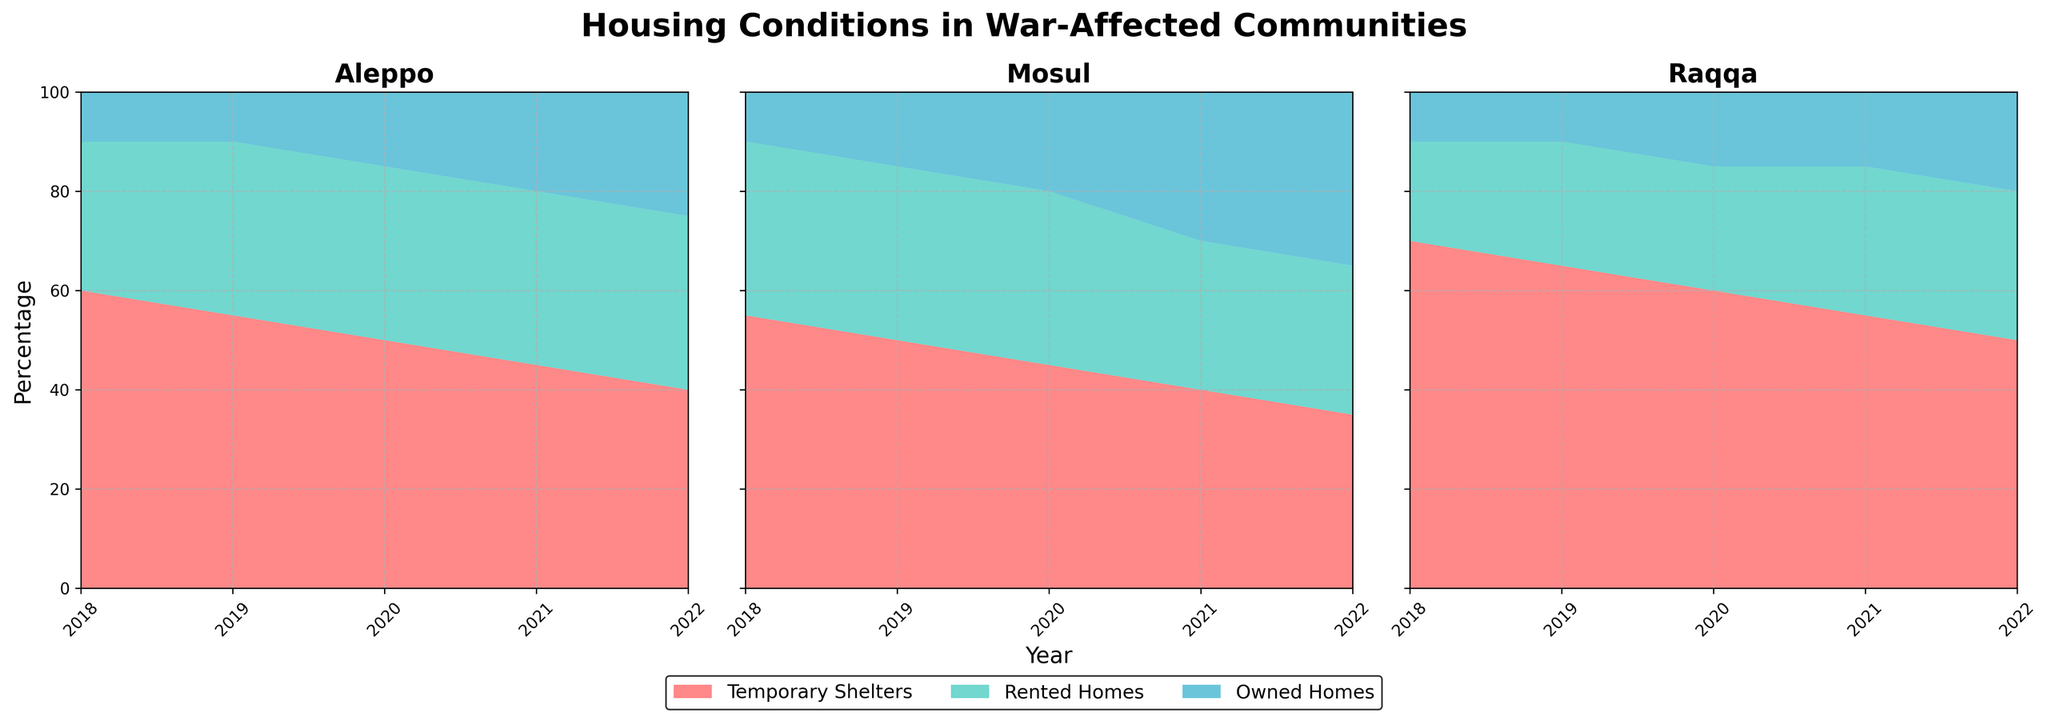What is the title of the chart? The title is given at the top of the chart and typically describes the main topic or focus of the figure.
Answer: Housing Conditions in War-Affected Communities Which community had the highest percentage of temporary shelters in 2018? Look at the stack for 2018 and compare the height of the temporary shelters area for each community.
Answer: Raqqa In Aleppo, how did the percentage of owned homes change from 2018 to 2022? Observe the height of the owned homes area in Aleppo's segment from 2018 to 2022 to see how it changed over the years.
Answer: Increased from 10% to 25% Which community showed the most significant change in the percentage of rented homes from 2018 to 2022? Compare the heights of the rented homes area for all communities between 2018 and 2022 to determine which one had the largest change.
Answer: Mosul What is the overall trend in the percentage of temporary shelters in Raqqa from 2018 to 2022? Track the span of the temporary shelters area in Raqqa's segment across the years to identify the trend.
Answer: Decreasing trend How did the total percentage of owned and rented homes in Mosul change between 2018 and 2021? Add the percentages of rented and owned homes in Mosul for 2018 and 2021 and then compare them.
Answer: Increased from 45% to 60% Which type of housing shows a general increase across all communities from 2018 to 2022? Check the overall trend for each housing type in all three communities to determine which one shows a general rise.
Answer: Owned Homes In 2021, which community had the smallest percentage of temporary shelters? Compare the heights of the temporary shelters areas within the 2021 timeframe for all the communities.
Answer: Mosul What is the relationship between rented homes and owned homes in Aleppo from 2018 to 2022? Examine the height of the rented homes and owned homes areas in Aleppo across the years to understand how they are related or if one increases when the other decreases.
Answer: Generally, rented homes remain constant while owned homes increase Are temporary shelters generally decreasing, increasing, or fluctuating across years in Aleppo? Track the span of the temporary shelters area in Aleppo's segment over the years to determine the trend.
Answer: Decreasing 